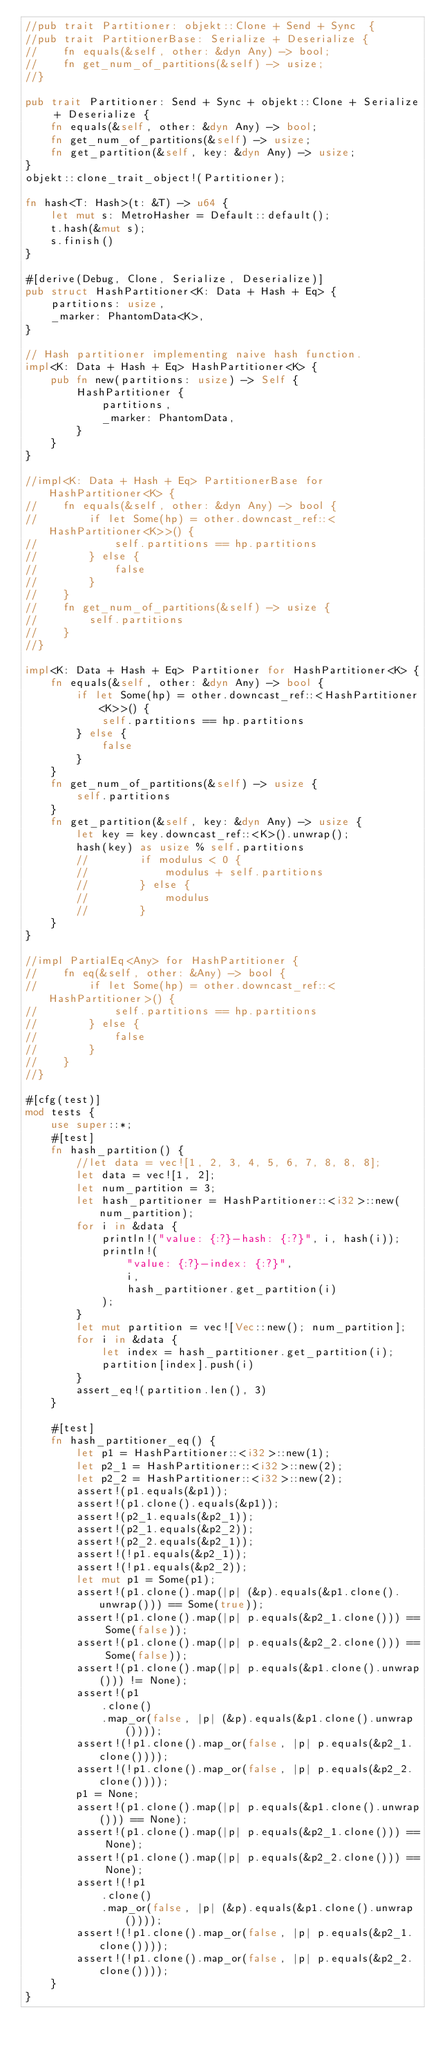Convert code to text. <code><loc_0><loc_0><loc_500><loc_500><_Rust_>//pub trait Partitioner: objekt::Clone + Send + Sync  {
//pub trait PartitionerBase: Serialize + Deserialize {
//    fn equals(&self, other: &dyn Any) -> bool;
//    fn get_num_of_partitions(&self) -> usize;
//}

pub trait Partitioner: Send + Sync + objekt::Clone + Serialize + Deserialize {
    fn equals(&self, other: &dyn Any) -> bool;
    fn get_num_of_partitions(&self) -> usize;
    fn get_partition(&self, key: &dyn Any) -> usize;
}
objekt::clone_trait_object!(Partitioner);

fn hash<T: Hash>(t: &T) -> u64 {
    let mut s: MetroHasher = Default::default();
    t.hash(&mut s);
    s.finish()
}

#[derive(Debug, Clone, Serialize, Deserialize)]
pub struct HashPartitioner<K: Data + Hash + Eq> {
    partitions: usize,
    _marker: PhantomData<K>,
}

// Hash partitioner implementing naive hash function.
impl<K: Data + Hash + Eq> HashPartitioner<K> {
    pub fn new(partitions: usize) -> Self {
        HashPartitioner {
            partitions,
            _marker: PhantomData,
        }
    }
}

//impl<K: Data + Hash + Eq> PartitionerBase for HashPartitioner<K> {
//    fn equals(&self, other: &dyn Any) -> bool {
//        if let Some(hp) = other.downcast_ref::<HashPartitioner<K>>() {
//            self.partitions == hp.partitions
//        } else {
//            false
//        }
//    }
//    fn get_num_of_partitions(&self) -> usize {
//        self.partitions
//    }
//}

impl<K: Data + Hash + Eq> Partitioner for HashPartitioner<K> {
    fn equals(&self, other: &dyn Any) -> bool {
        if let Some(hp) = other.downcast_ref::<HashPartitioner<K>>() {
            self.partitions == hp.partitions
        } else {
            false
        }
    }
    fn get_num_of_partitions(&self) -> usize {
        self.partitions
    }
    fn get_partition(&self, key: &dyn Any) -> usize {
        let key = key.downcast_ref::<K>().unwrap();
        hash(key) as usize % self.partitions
        //        if modulus < 0 {
        //            modulus + self.partitions
        //        } else {
        //            modulus
        //        }
    }
}

//impl PartialEq<Any> for HashPartitioner {
//    fn eq(&self, other: &Any) -> bool {
//        if let Some(hp) = other.downcast_ref::<HashPartitioner>() {
//            self.partitions == hp.partitions
//        } else {
//            false
//        }
//    }
//}

#[cfg(test)]
mod tests {
    use super::*;
    #[test]
    fn hash_partition() {
        //let data = vec![1, 2, 3, 4, 5, 6, 7, 8, 8, 8];
        let data = vec![1, 2];
        let num_partition = 3;
        let hash_partitioner = HashPartitioner::<i32>::new(num_partition);
        for i in &data {
            println!("value: {:?}-hash: {:?}", i, hash(i));
            println!(
                "value: {:?}-index: {:?}",
                i,
                hash_partitioner.get_partition(i)
            );
        }
        let mut partition = vec![Vec::new(); num_partition];
        for i in &data {
            let index = hash_partitioner.get_partition(i);
            partition[index].push(i)
        }
        assert_eq!(partition.len(), 3)
    }

    #[test]
    fn hash_partitioner_eq() {
        let p1 = HashPartitioner::<i32>::new(1);
        let p2_1 = HashPartitioner::<i32>::new(2);
        let p2_2 = HashPartitioner::<i32>::new(2);
        assert!(p1.equals(&p1));
        assert!(p1.clone().equals(&p1));
        assert!(p2_1.equals(&p2_1));
        assert!(p2_1.equals(&p2_2));
        assert!(p2_2.equals(&p2_1));
        assert!(!p1.equals(&p2_1));
        assert!(!p1.equals(&p2_2));
        let mut p1 = Some(p1);
        assert!(p1.clone().map(|p| (&p).equals(&p1.clone().unwrap())) == Some(true));
        assert!(p1.clone().map(|p| p.equals(&p2_1.clone())) == Some(false));
        assert!(p1.clone().map(|p| p.equals(&p2_2.clone())) == Some(false));
        assert!(p1.clone().map(|p| p.equals(&p1.clone().unwrap())) != None);
        assert!(p1
            .clone()
            .map_or(false, |p| (&p).equals(&p1.clone().unwrap())));
        assert!(!p1.clone().map_or(false, |p| p.equals(&p2_1.clone())));
        assert!(!p1.clone().map_or(false, |p| p.equals(&p2_2.clone())));
        p1 = None;
        assert!(p1.clone().map(|p| p.equals(&p1.clone().unwrap())) == None);
        assert!(p1.clone().map(|p| p.equals(&p2_1.clone())) == None);
        assert!(p1.clone().map(|p| p.equals(&p2_2.clone())) == None);
        assert!(!p1
            .clone()
            .map_or(false, |p| (&p).equals(&p1.clone().unwrap())));
        assert!(!p1.clone().map_or(false, |p| p.equals(&p2_1.clone())));
        assert!(!p1.clone().map_or(false, |p| p.equals(&p2_2.clone())));
    }
}
</code> 